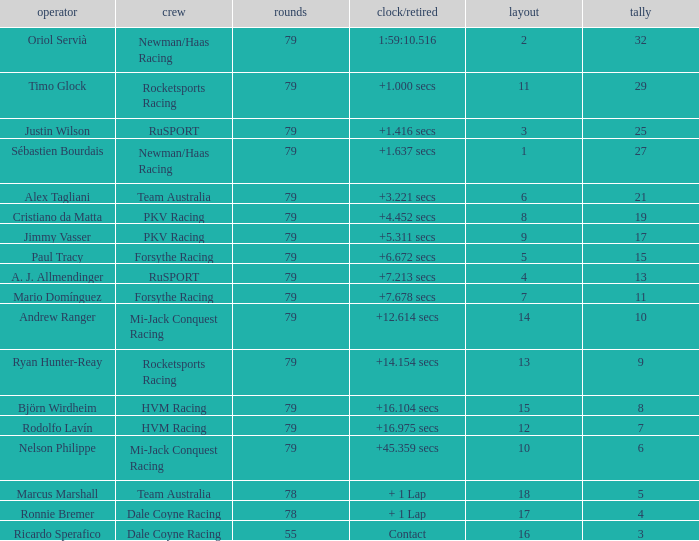Which points has the driver Paul Tracy? 15.0. 